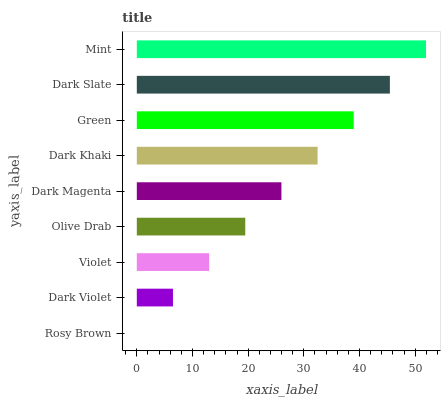Is Rosy Brown the minimum?
Answer yes or no. Yes. Is Mint the maximum?
Answer yes or no. Yes. Is Dark Violet the minimum?
Answer yes or no. No. Is Dark Violet the maximum?
Answer yes or no. No. Is Dark Violet greater than Rosy Brown?
Answer yes or no. Yes. Is Rosy Brown less than Dark Violet?
Answer yes or no. Yes. Is Rosy Brown greater than Dark Violet?
Answer yes or no. No. Is Dark Violet less than Rosy Brown?
Answer yes or no. No. Is Dark Magenta the high median?
Answer yes or no. Yes. Is Dark Magenta the low median?
Answer yes or no. Yes. Is Dark Slate the high median?
Answer yes or no. No. Is Olive Drab the low median?
Answer yes or no. No. 